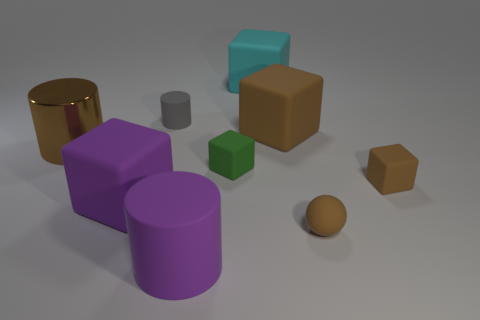Subtract all large rubber cylinders. How many cylinders are left? 2 Add 1 spheres. How many objects exist? 10 Subtract all cylinders. How many objects are left? 6 Subtract all gray cylinders. How many cylinders are left? 2 Subtract 5 blocks. How many blocks are left? 0 Subtract all blue balls. How many green cubes are left? 1 Subtract all cylinders. Subtract all cylinders. How many objects are left? 3 Add 2 small rubber cylinders. How many small rubber cylinders are left? 3 Add 2 matte blocks. How many matte blocks exist? 7 Subtract 0 yellow cubes. How many objects are left? 9 